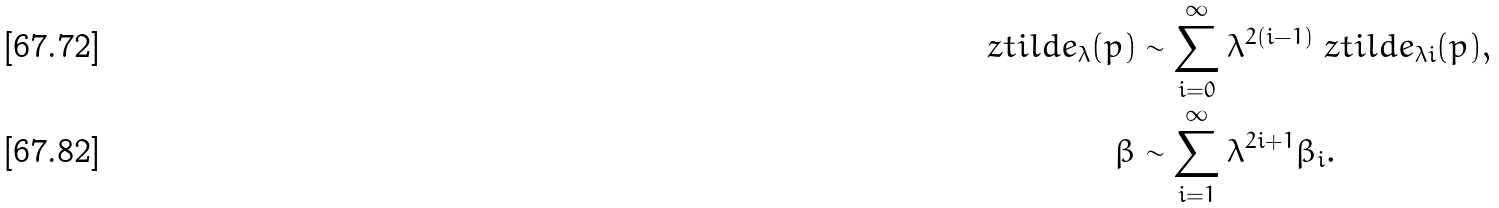<formula> <loc_0><loc_0><loc_500><loc_500>\ z t i l d e _ { \lambda } ( p ) & \sim \sum _ { i = 0 } ^ { \infty } \lambda ^ { 2 ( i - 1 ) } \ z t i l d e _ { \lambda i } ( p ) , \\ \beta & \sim \sum _ { i = 1 } ^ { \infty } \lambda ^ { 2 i + 1 } \beta _ { i } .</formula> 